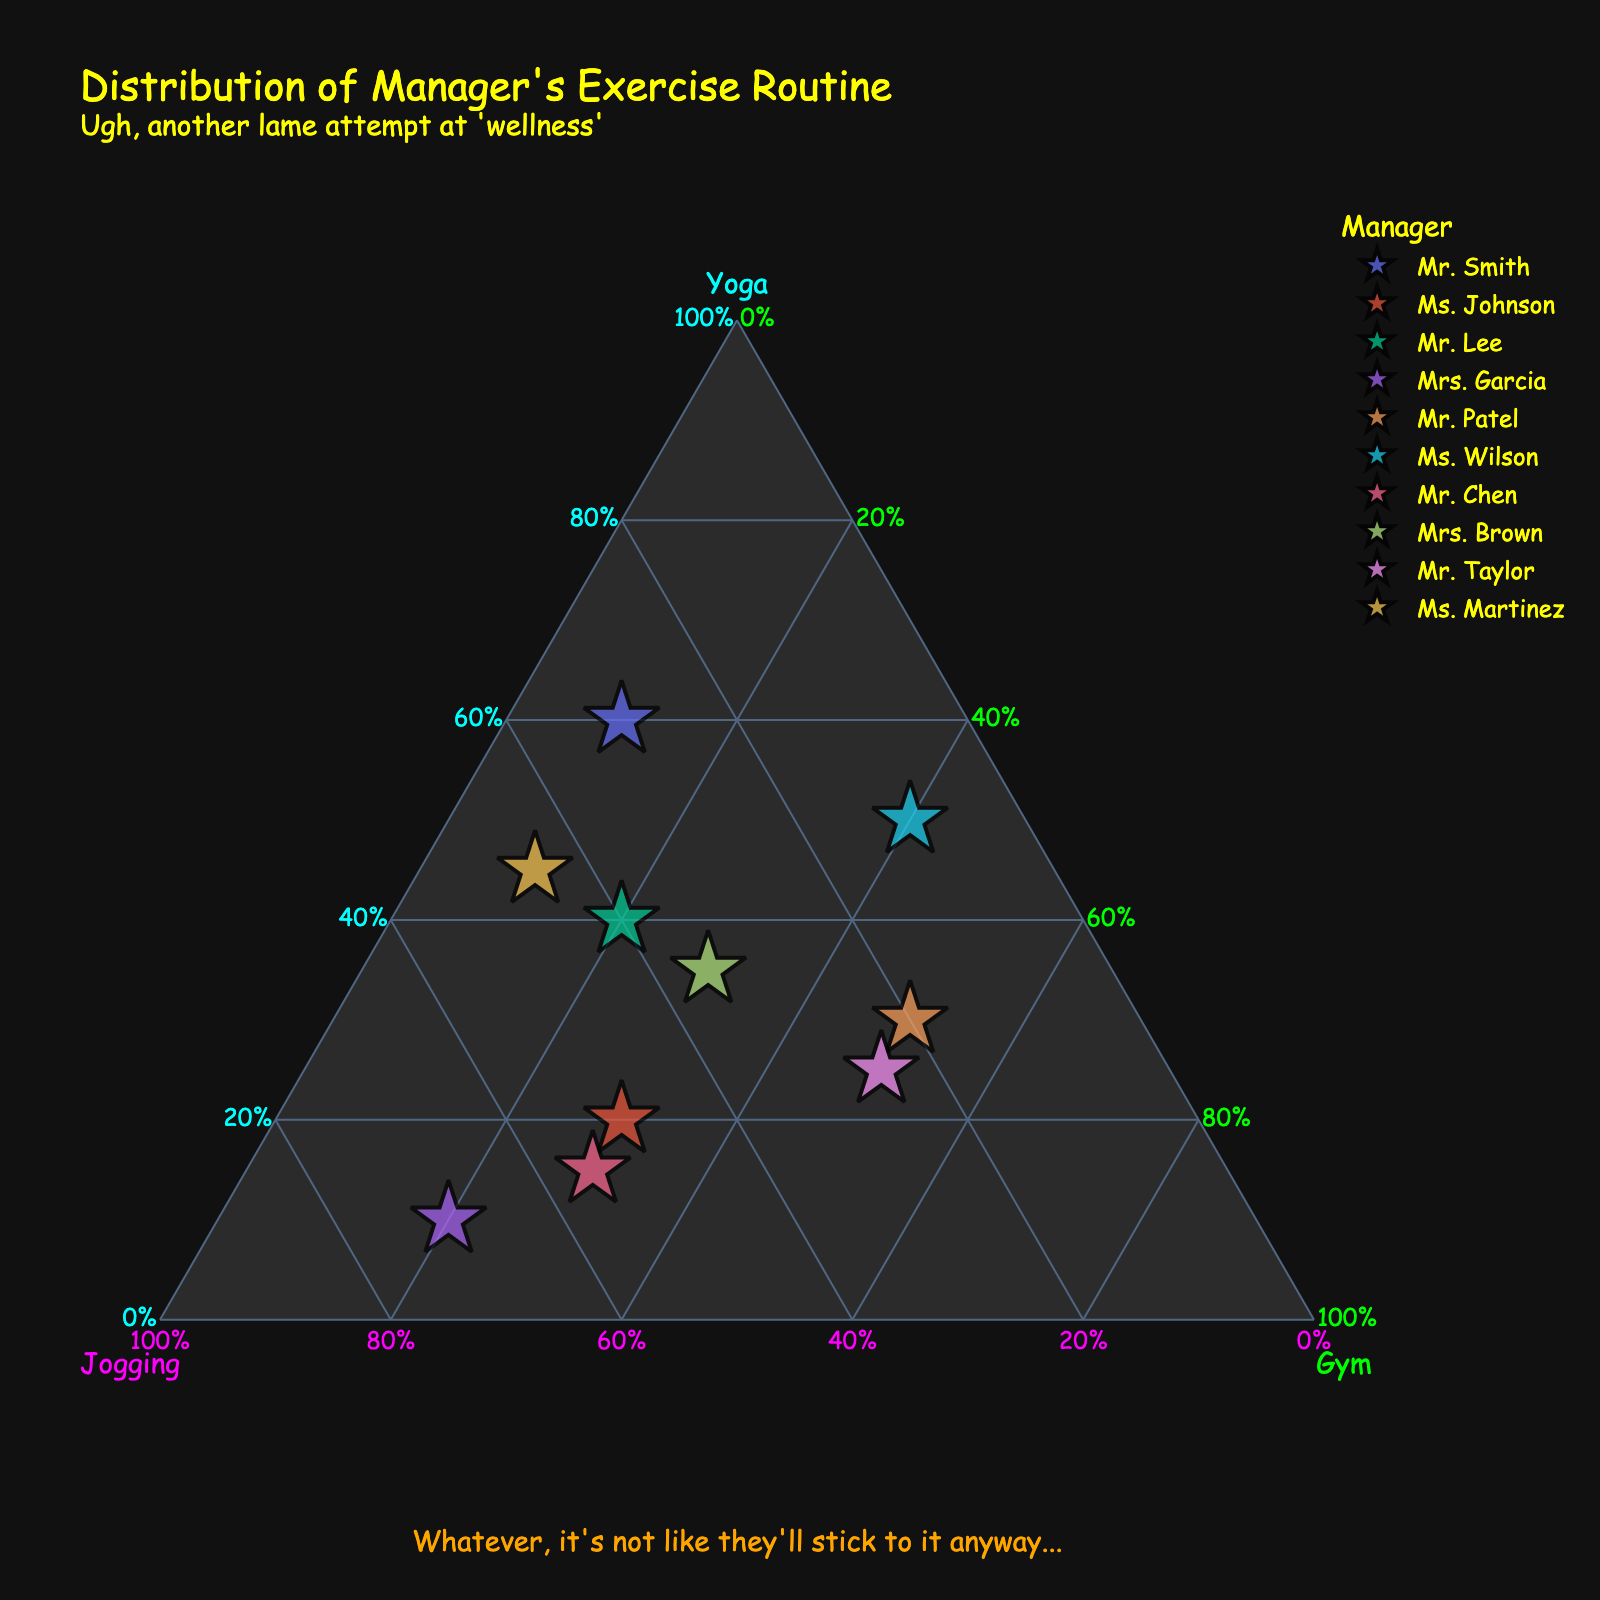how many managers are represented in the figure? There are 10 managers listed in the data provided: Mr. Smith, Ms. Johnson, Mr. Lee, Mrs. Garcia, Mr. Patel, Ms. Wilson, Mr. Chen, Mrs. Brown, Mr. Taylor, and Ms. Martinez. This count will correspond to the 10 data points in the figure.
Answer: 10 what's the title of the figure? The title of the figure is clearly stated on top.
Answer: Distribution of Manager's Exercise Routine which manager does the figure suggest has the highest proportion of yoga in their routine? By looking at the points closest to the axis labeled "Yoga," we can determine the manager with the highest yoga proportion. Mr. Smith is closest to this axis with 60% yoga.
Answer: Mr. Smith which manager's workout routine is the closest to an equal distribution of yoga, jogging, and gym? To find this, we look for the point near the center of the ternary plot where all proportions are roughly equal. Mrs. Brown with 35% yoga, 35% jogging, and 30% gym is closest to this distribution.
Answer: Mrs. Brown between jogging and gym workouts, which activity does Ms. Wilson prefer more? By examining the position relative to the "Jogging" and "Gym" axes, Ms. Wilson's jogging proportion is 10%, and her gym proportion is 40%. Thus, she prefers gym workouts more.
Answer: Gym workouts which manager has an equal routine of yoga and jogging, but also with some gym included? Looking at data points where the "Yoga" and "Jogging" percentages are the same, Mr. Lee with 40% yoga and 40% jogging, and 20% gym matches this description.
Answer: Mr. Lee what's the average proportion of gym workouts among all managers? First, sum all gym workout percentages: 10 + 30 + 20 + 20 + 50 + 40 + 30 + 30 + 50 + 10 = 290. There are 10 managers, so the average gym proportion is 290/10 = 29%.
Answer: 29% who has the closest proportions between all three activities, and what are those values? By looking for the point that seems almost equidistant from all three axes, Mrs. Brown with 35% yoga, 35% jogging, and 30% gym workouts has the closest proportions.
Answer: Mrs. Brown with 35% yoga, 35% jogging, and 30% gym are there any managers who include more than 50% of any single activity in their routine? Examining the normalized data, Mr. Smith (60% yoga), Ms. Johnson (50% jogging), Mrs. Garcia (70% jogging), and Mr. Chen (55% jogging) all include more than 50% of a single activity.
Answer: Yes which manager's routine is the most unlike Mrs. Garcia's? Mrs. Garcia has a high jogging proportion (70%). Looking for the point farthest from this value relative to each corner, Ms. Wilson with low jogging (10%) and high gym (40%) proportions is the most unlike Mrs. Garcia's routine.
Answer: Ms. Wilson 